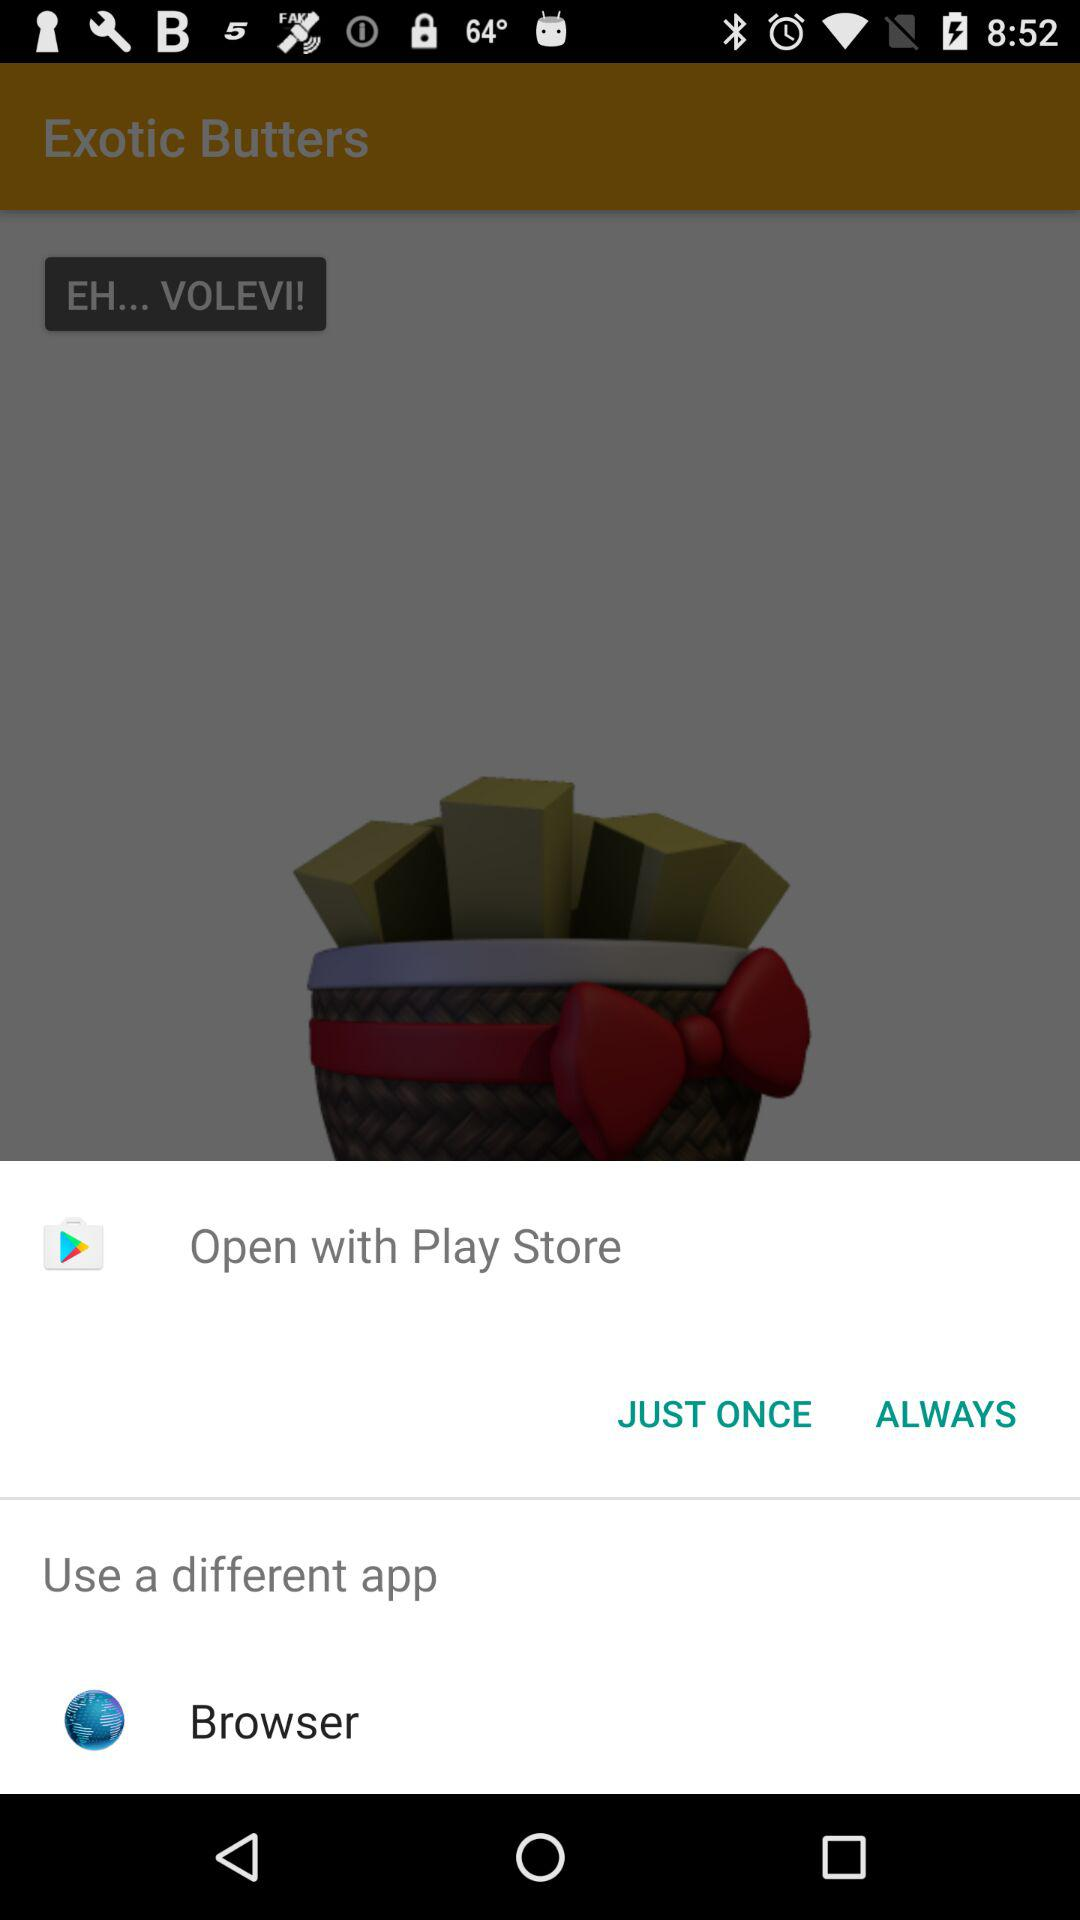What options are given for opening? The options are "Play Store" and "Browser". 